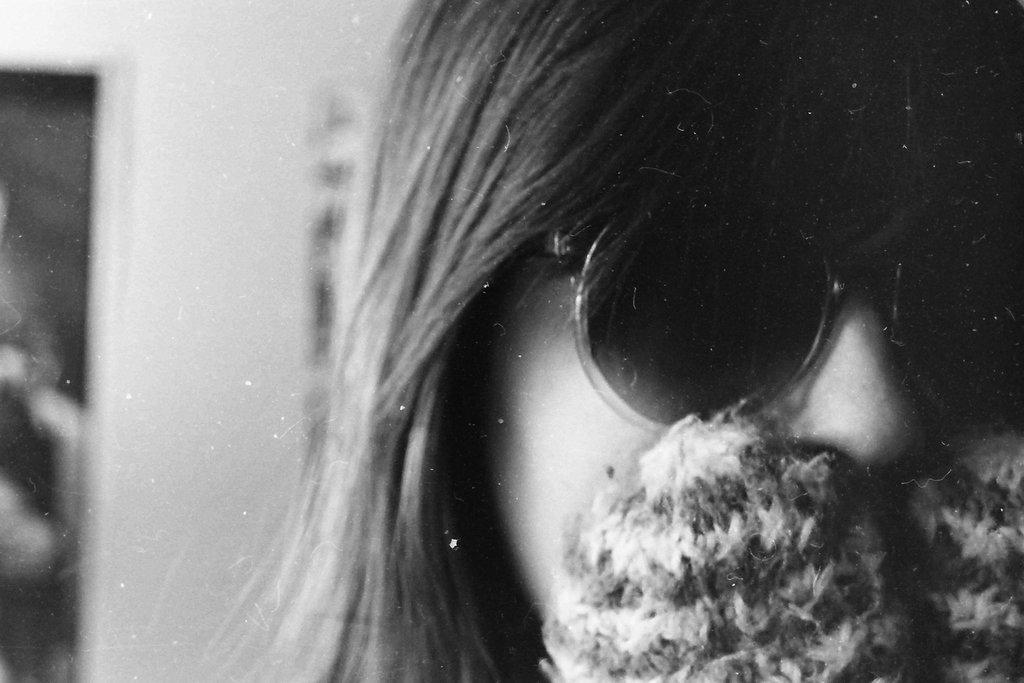Could you give a brief overview of what you see in this image? In this image I can see a persons face who is wearing goggles which are black in color. In the background I can see the wall and few other objects. 